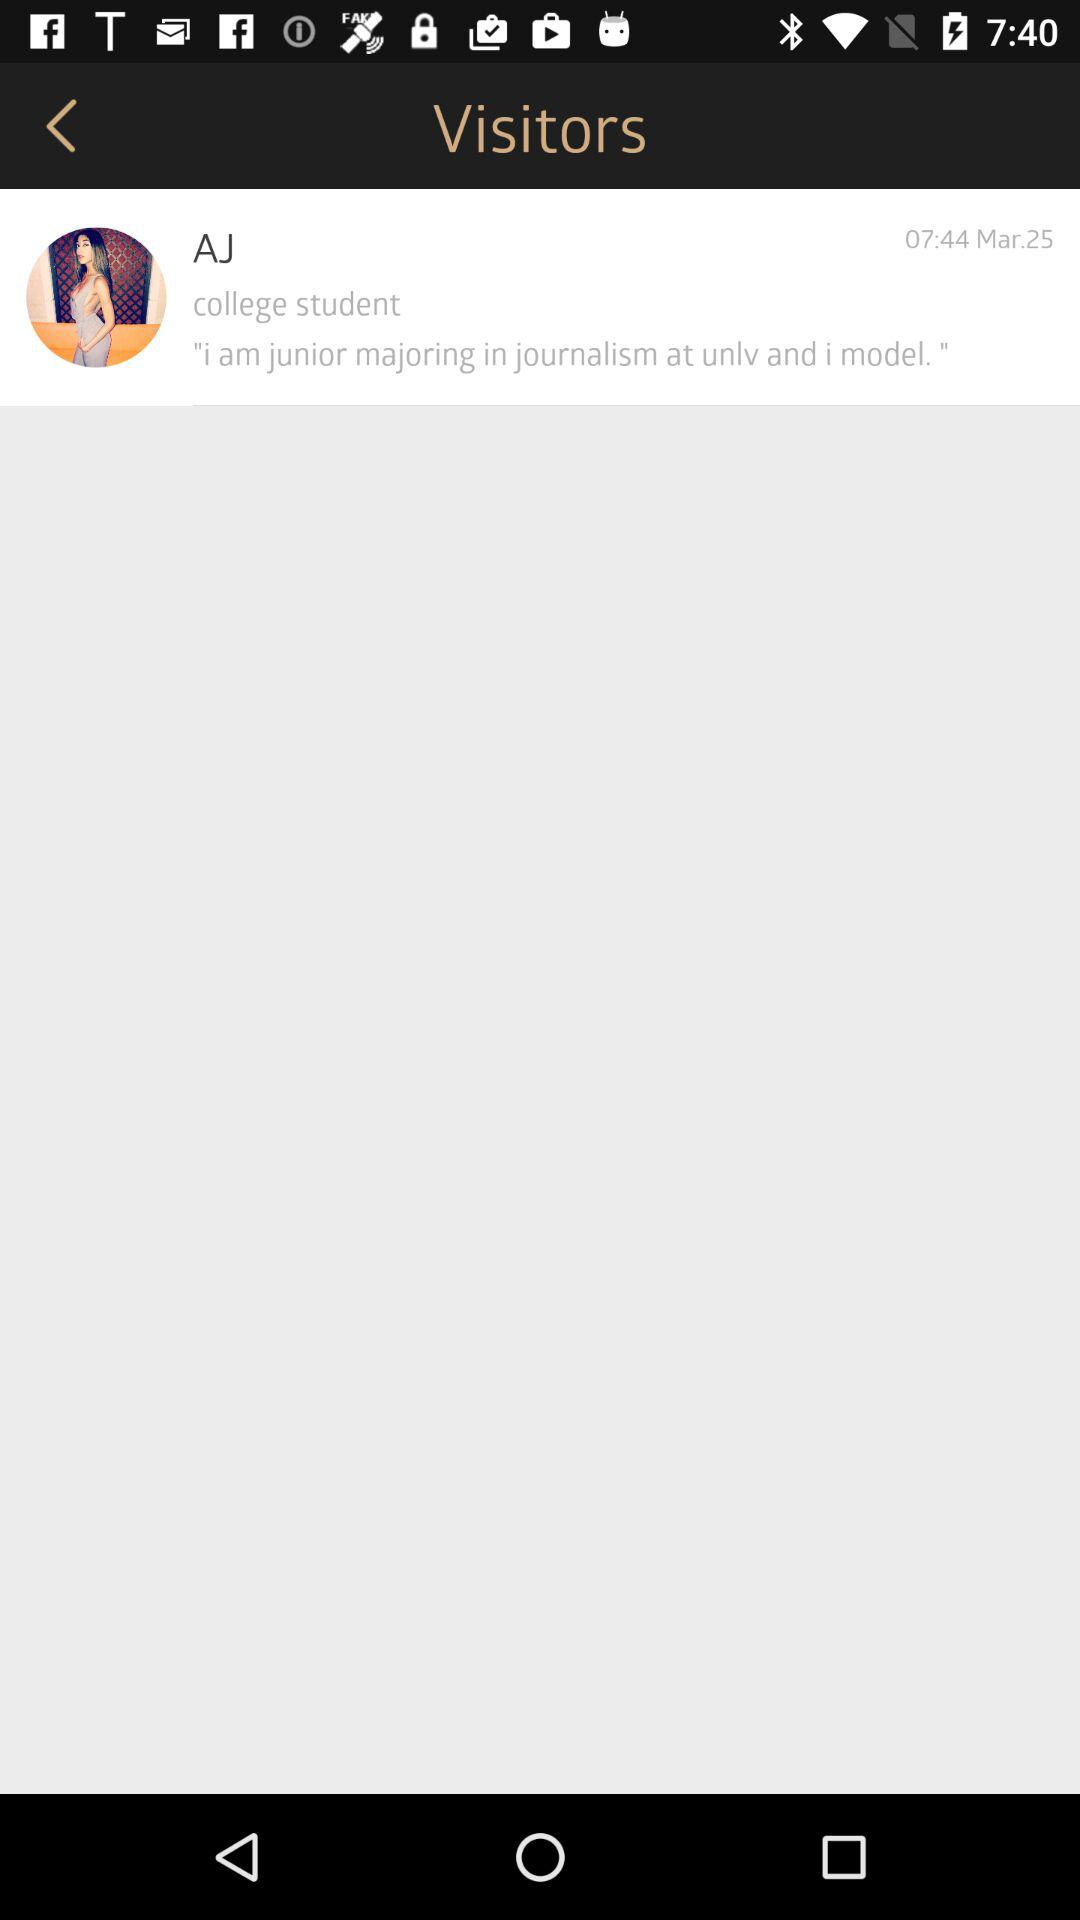What is the mentioned date? The mentioned date is March 25. 